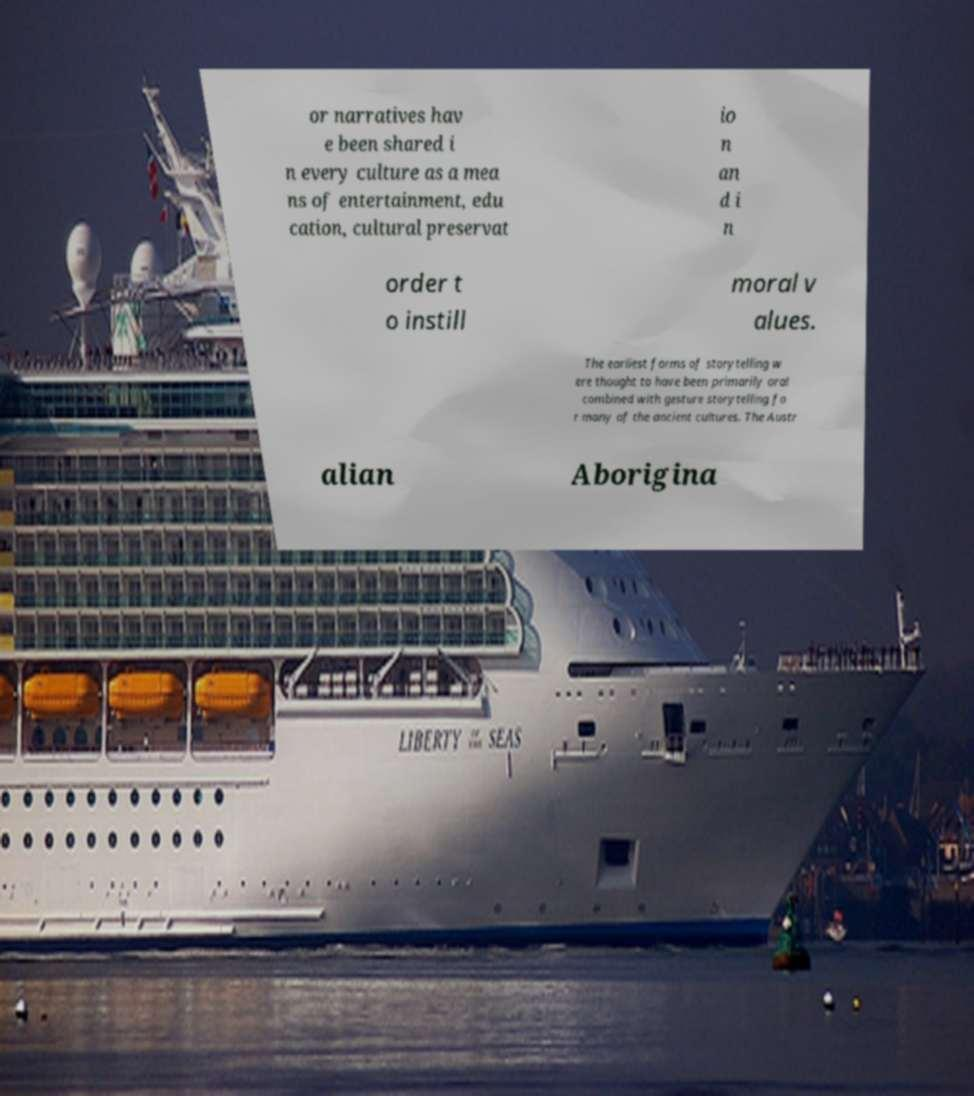Could you assist in decoding the text presented in this image and type it out clearly? or narratives hav e been shared i n every culture as a mea ns of entertainment, edu cation, cultural preservat io n an d i n order t o instill moral v alues. The earliest forms of storytelling w ere thought to have been primarily oral combined with gesture storytelling fo r many of the ancient cultures. The Austr alian Aborigina 